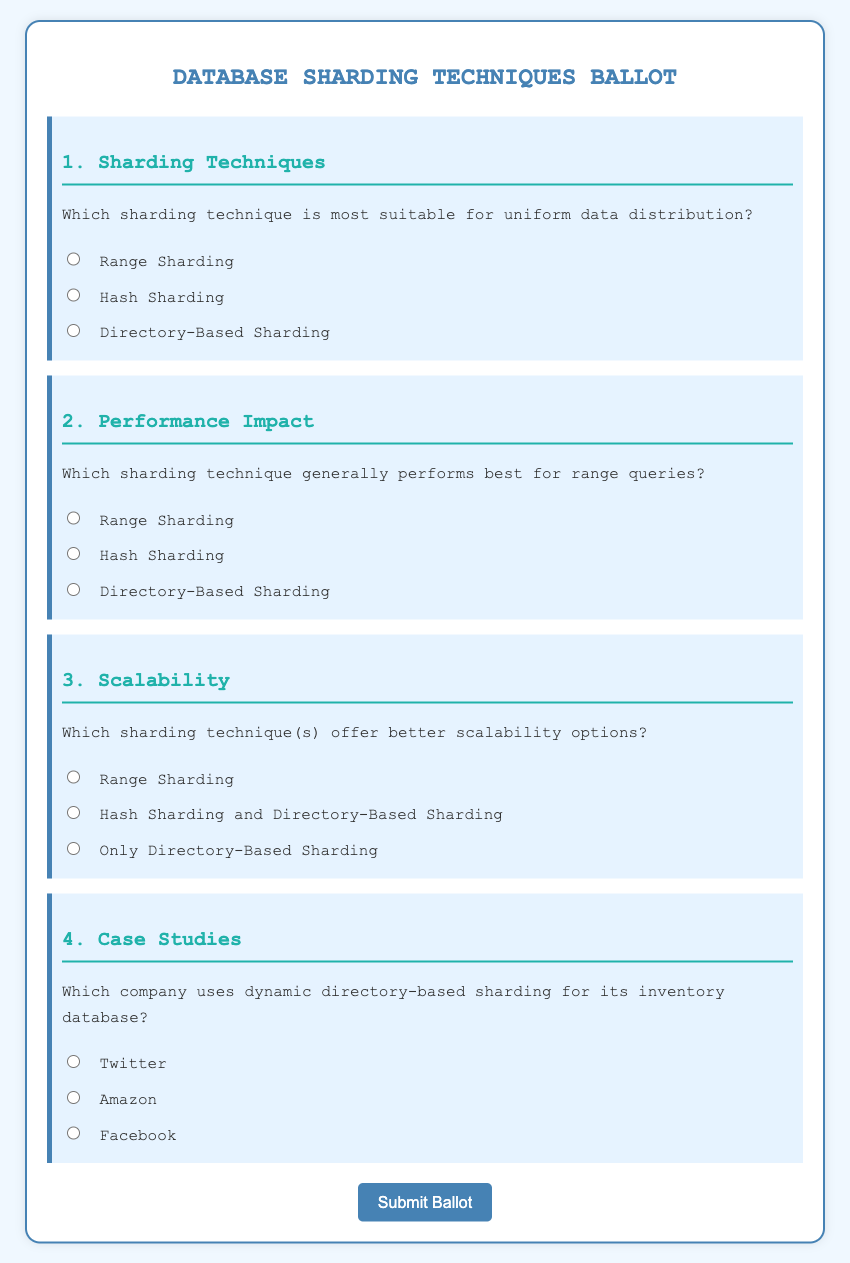What is the title of the document? The title is indicated in the header section of the document, which is "Database Sharding Techniques Ballot."
Answer: Database Sharding Techniques Ballot How many questions are in the ballot? There are four questions listed in the document, each with a distinct category related to sharding techniques.
Answer: 4 What is the first sharding technique mentioned? The first question addresses sharding techniques, where the first option is "Range Sharding."
Answer: Range Sharding Which sharding technique is suggested for better performance with range queries? The second question asks for the best-performing sharding technique for range queries, which is "Range Sharding."
Answer: Range Sharding What company is mentioned as using dynamic directory-based sharding? The fourth question points to a company known for using dynamic directory-based sharding, which is "Twitter."
Answer: Twitter Which sharding technique is associated with better scalability options? The third question asks which techniques offer better scalability, indicating "Hash Sharding and Directory-Based Sharding."
Answer: Hash Sharding and Directory-Based Sharding What color is used for the background of the ballot? The background color of the ballot is specified as "#f0f8ff."
Answer: #f0f8ff What is the text color of the document? The text color for the document is defined as "#333."
Answer: #333 What type of input options does the form utilize? The form uses radio buttons for each question's options to allow single selection for the answers.
Answer: Radio buttons 